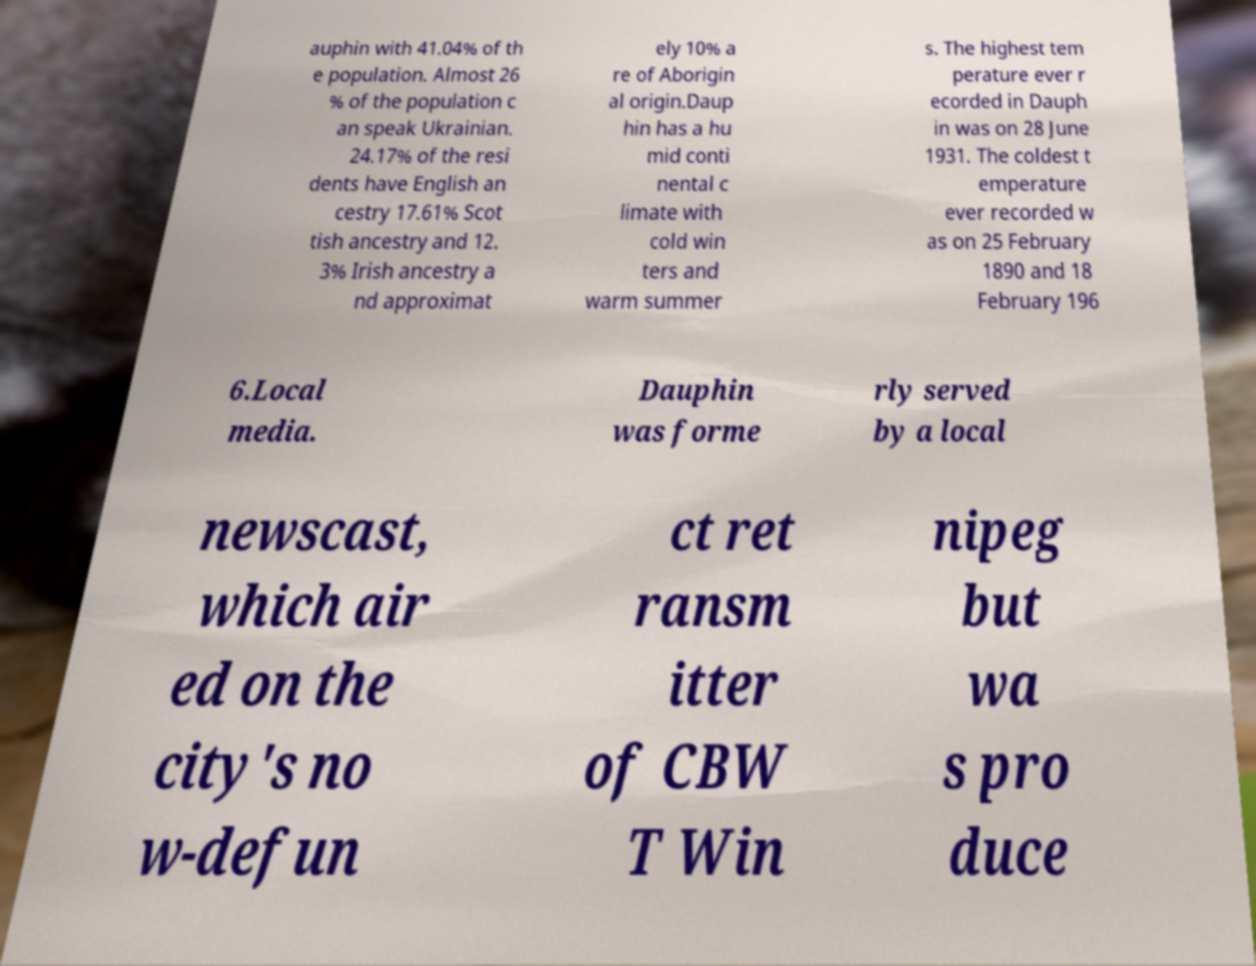Please read and relay the text visible in this image. What does it say? auphin with 41.04% of th e population. Almost 26 % of the population c an speak Ukrainian. 24.17% of the resi dents have English an cestry 17.61% Scot tish ancestry and 12. 3% Irish ancestry a nd approximat ely 10% a re of Aborigin al origin.Daup hin has a hu mid conti nental c limate with cold win ters and warm summer s. The highest tem perature ever r ecorded in Dauph in was on 28 June 1931. The coldest t emperature ever recorded w as on 25 February 1890 and 18 February 196 6.Local media. Dauphin was forme rly served by a local newscast, which air ed on the city's no w-defun ct ret ransm itter of CBW T Win nipeg but wa s pro duce 